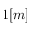Convert formula to latex. <formula><loc_0><loc_0><loc_500><loc_500>1 [ m ]</formula> 